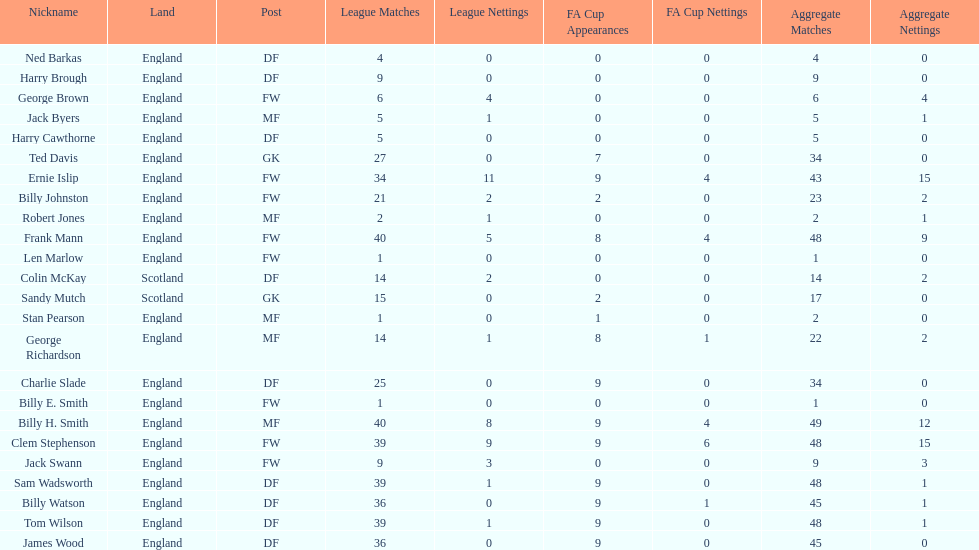In which nation can you find the most appearances? England. 